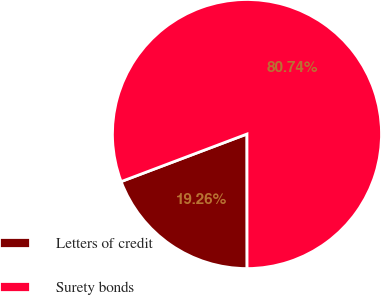<chart> <loc_0><loc_0><loc_500><loc_500><pie_chart><fcel>Letters of credit<fcel>Surety bonds<nl><fcel>19.26%<fcel>80.74%<nl></chart> 